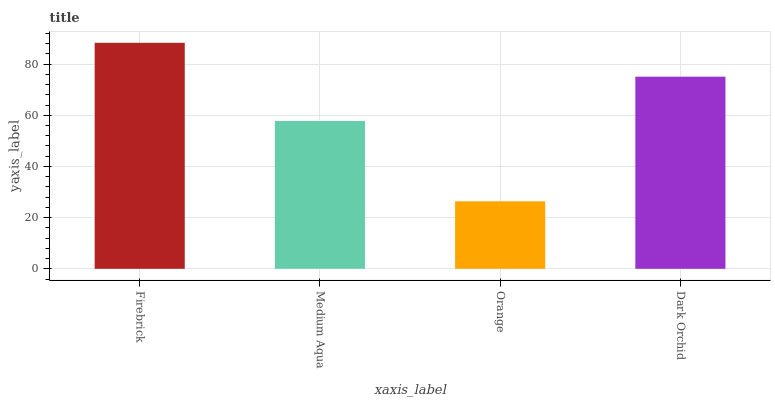Is Medium Aqua the minimum?
Answer yes or no. No. Is Medium Aqua the maximum?
Answer yes or no. No. Is Firebrick greater than Medium Aqua?
Answer yes or no. Yes. Is Medium Aqua less than Firebrick?
Answer yes or no. Yes. Is Medium Aqua greater than Firebrick?
Answer yes or no. No. Is Firebrick less than Medium Aqua?
Answer yes or no. No. Is Dark Orchid the high median?
Answer yes or no. Yes. Is Medium Aqua the low median?
Answer yes or no. Yes. Is Orange the high median?
Answer yes or no. No. Is Dark Orchid the low median?
Answer yes or no. No. 